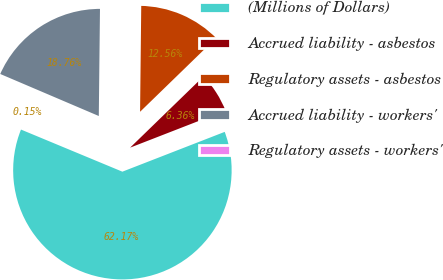Convert chart. <chart><loc_0><loc_0><loc_500><loc_500><pie_chart><fcel>(Millions of Dollars)<fcel>Accrued liability - asbestos<fcel>Regulatory assets - asbestos<fcel>Accrued liability - workers'<fcel>Regulatory assets - workers'<nl><fcel>62.17%<fcel>6.36%<fcel>12.56%<fcel>18.76%<fcel>0.15%<nl></chart> 